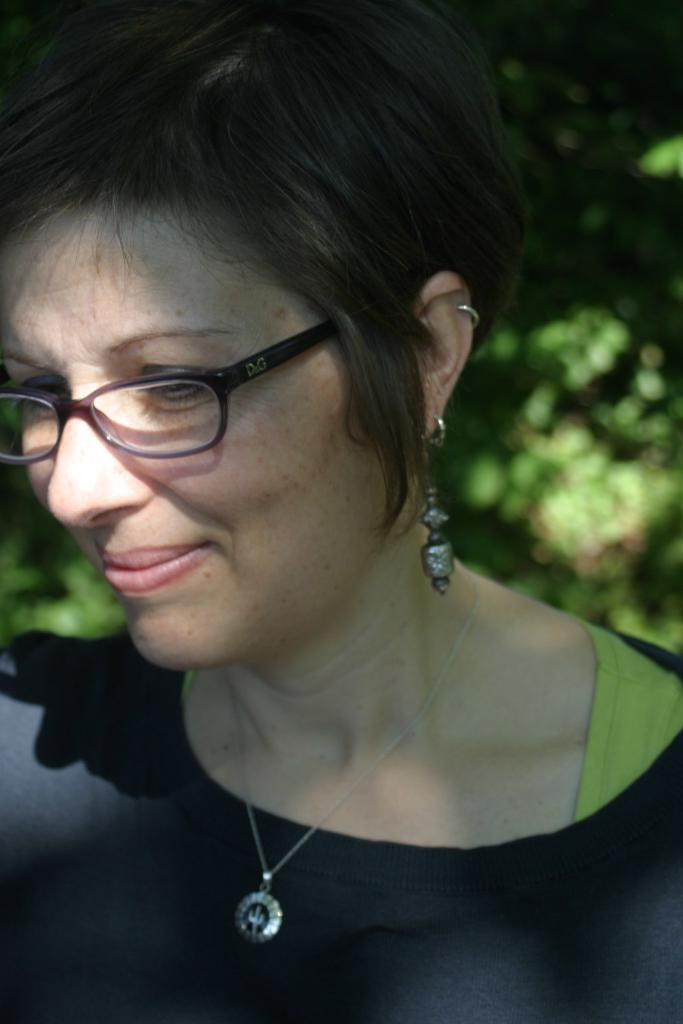Who is present in the image? There is a woman in the image. What is the woman doing in the image? The woman is smiling in the image. What accessories is the woman wearing in the image? The woman is wearing spectacles, a chain, and earrings in the image. What is the woman wearing in the image? The woman is wearing a black dress in the image. What can be seen in the background of the image? There are plants in the background of the image. What type of blade is the woman using to cut the plants in the image? There is no blade present in the image, and the woman is not cutting any plants. 